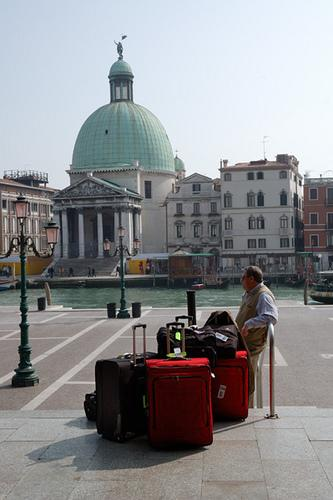What mode of transport did this person recently take advantage of?

Choices:
A) lyft
B) biike
C) uber
D) air travel air travel 